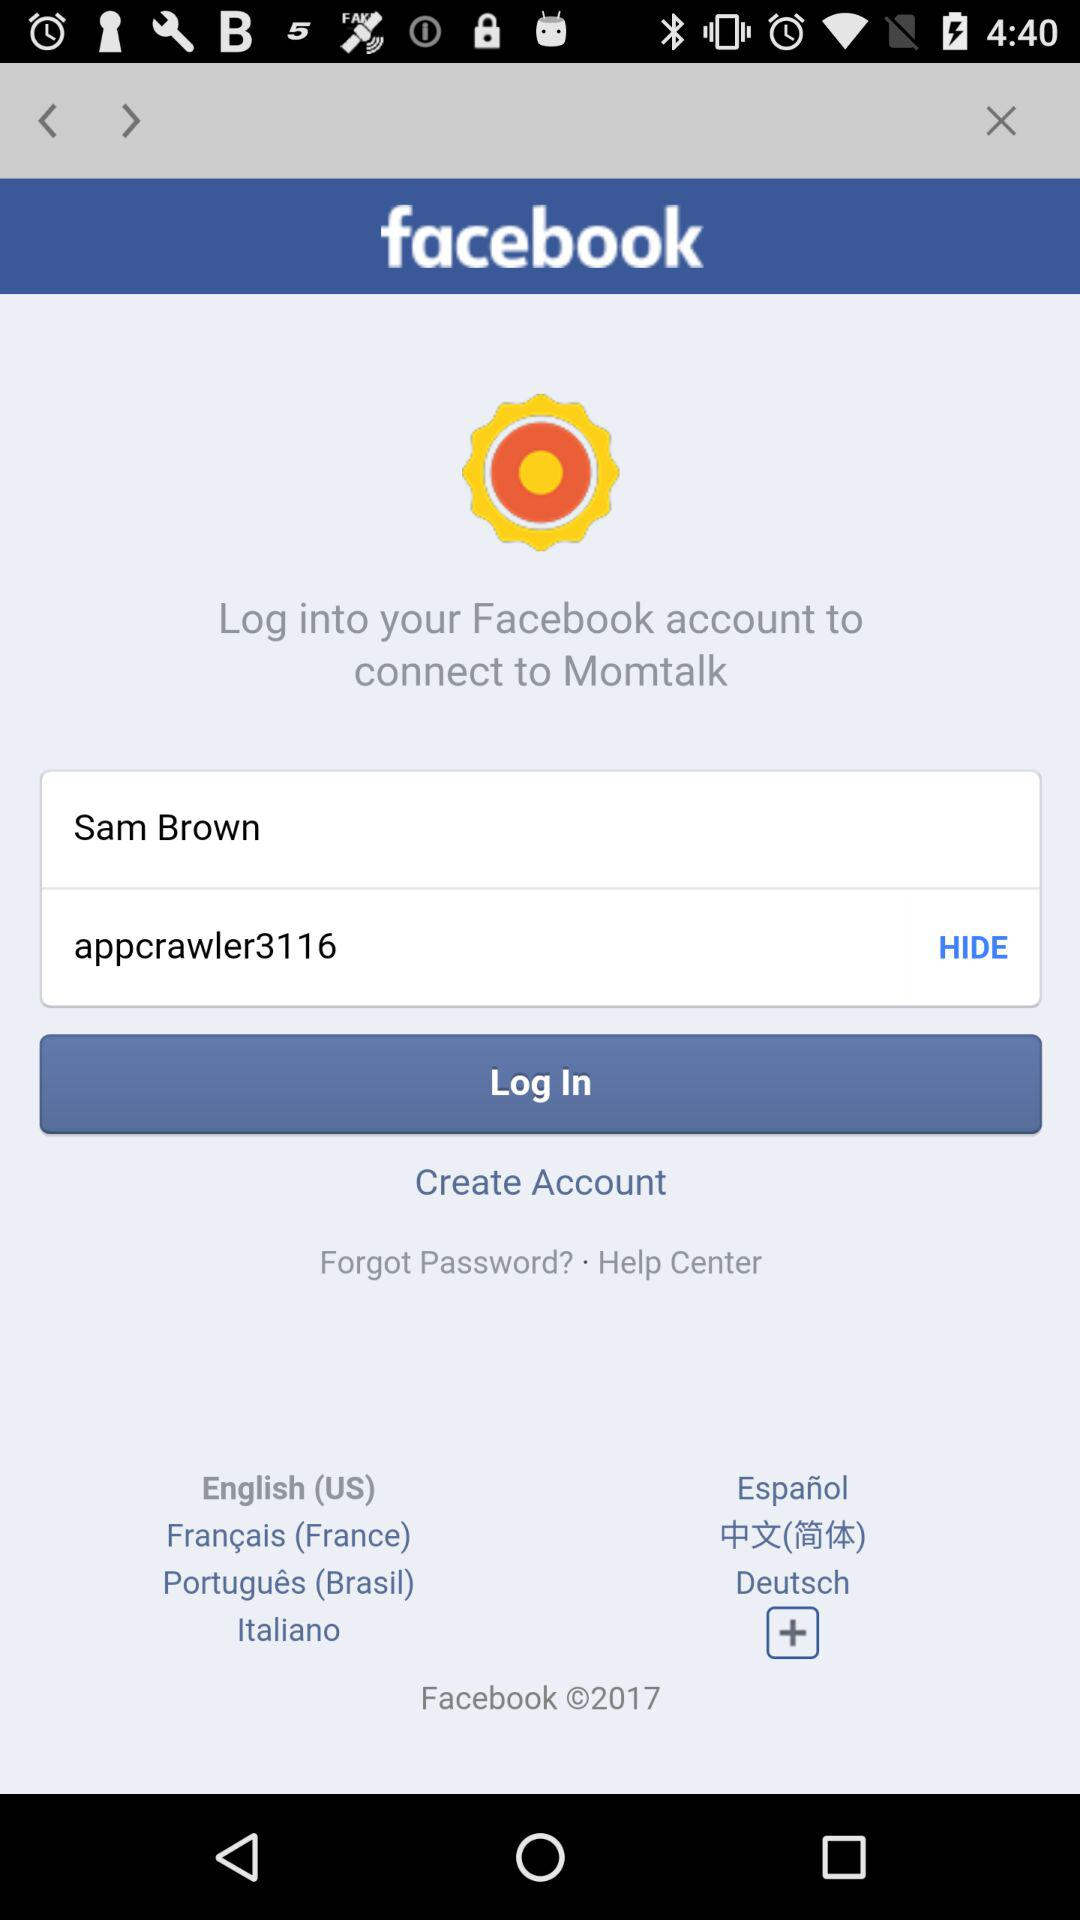What is the password? The password is "appcrawler3116". 